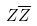<formula> <loc_0><loc_0><loc_500><loc_500>Z \overline { Z }</formula> 